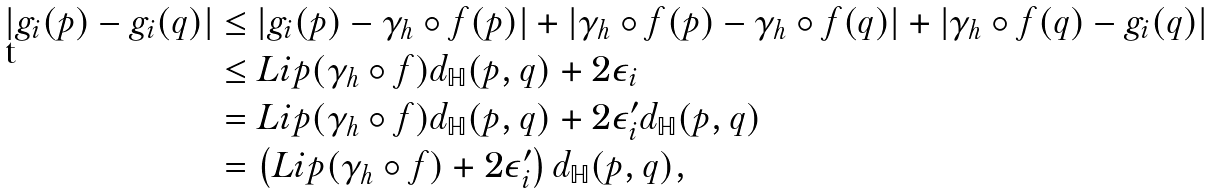Convert formula to latex. <formula><loc_0><loc_0><loc_500><loc_500>\left | g _ { i } ( p ) - g _ { i } ( q ) \right | & \leq \left | g _ { i } ( p ) - \gamma _ { h } \circ f ( p ) \right | + \left | \gamma _ { h } \circ f ( p ) - \gamma _ { h } \circ f ( q ) \right | + \left | \gamma _ { h } \circ f ( q ) - g _ { i } ( q ) \right | \\ & \leq L i p ( \gamma _ { h } \circ f ) d _ { \mathbb { H } } ( p , q ) + 2 \epsilon _ { i } \\ & = L i p ( \gamma _ { h } \circ f ) d _ { \mathbb { H } } ( p , q ) + 2 \epsilon ^ { \prime } _ { i } d _ { \mathbb { H } } ( p , q ) \\ & = \left ( L i p ( \gamma _ { h } \circ f ) + 2 \epsilon ^ { \prime } _ { i } \right ) d _ { \mathbb { H } } ( p , q ) ,</formula> 